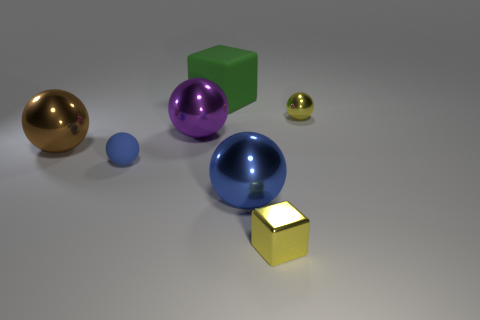Is the size of the rubber cube the same as the cube that is right of the large blue metal ball?
Ensure brevity in your answer.  No. Is the number of large brown objects that are on the left side of the large matte cube greater than the number of tiny gray metal things?
Ensure brevity in your answer.  Yes. What size is the brown object that is the same material as the large purple object?
Offer a terse response. Large. Is there a shiny block that has the same color as the small metallic ball?
Give a very brief answer. Yes. How many objects are either small gray cylinders or objects right of the big rubber block?
Keep it short and to the point. 3. Is the number of blue metal objects greater than the number of large brown metal cylinders?
Your answer should be compact. Yes. There is a thing that is the same color as the shiny cube; what is its size?
Your response must be concise. Small. Are there any tiny balls made of the same material as the green object?
Give a very brief answer. Yes. The metallic thing that is to the right of the blue shiny object and behind the matte ball has what shape?
Keep it short and to the point. Sphere. What number of other objects are there of the same shape as the tiny blue matte object?
Make the answer very short. 4. 